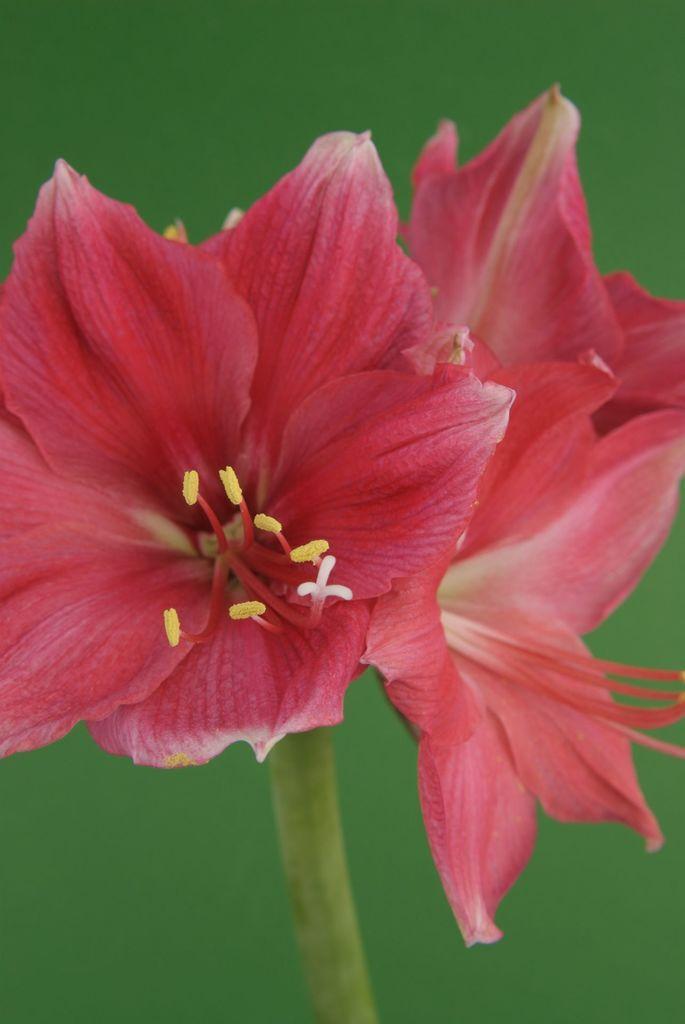Can you describe this image briefly? In this image we can see flowers which are in red color. 